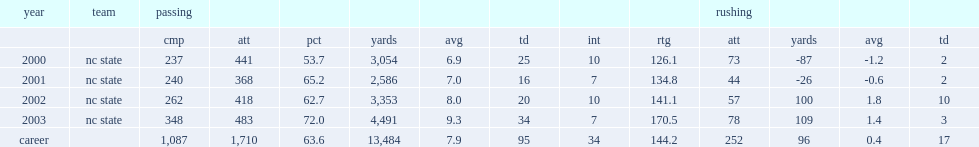Could you help me parse every detail presented in this table? {'header': ['year', 'team', 'passing', '', '', '', '', '', '', '', 'rushing', '', '', ''], 'rows': [['', '', 'cmp', 'att', 'pct', 'yards', 'avg', 'td', 'int', 'rtg', 'att', 'yards', 'avg', 'td'], ['2000', 'nc state', '237', '441', '53.7', '3,054', '6.9', '25', '10', '126.1', '73', '-87', '-1.2', '2'], ['2001', 'nc state', '240', '368', '65.2', '2,586', '7.0', '16', '7', '134.8', '44', '-26', '-0.6', '2'], ['2002', 'nc state', '262', '418', '62.7', '3,353', '8.0', '20', '10', '141.1', '57', '100', '1.8', '10'], ['2003', 'nc state', '348', '483', '72.0', '4,491', '9.3', '34', '7', '170.5', '78', '109', '1.4', '3'], ['career', '', '1,087', '1,710', '63.6', '13,484', '7.9', '95', '34', '144.2', '252', '96', '0.4', '17']]} How many passing yards did rivers get in 2000? 3054.0. 